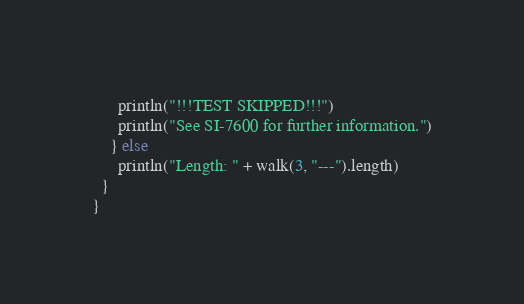Convert code to text. <code><loc_0><loc_0><loc_500><loc_500><_Scala_>      println("!!!TEST SKIPPED!!!")
      println("See SI-7600 for further information.")
    } else
      println("Length: " + walk(3, "---").length)
  }
}
</code> 